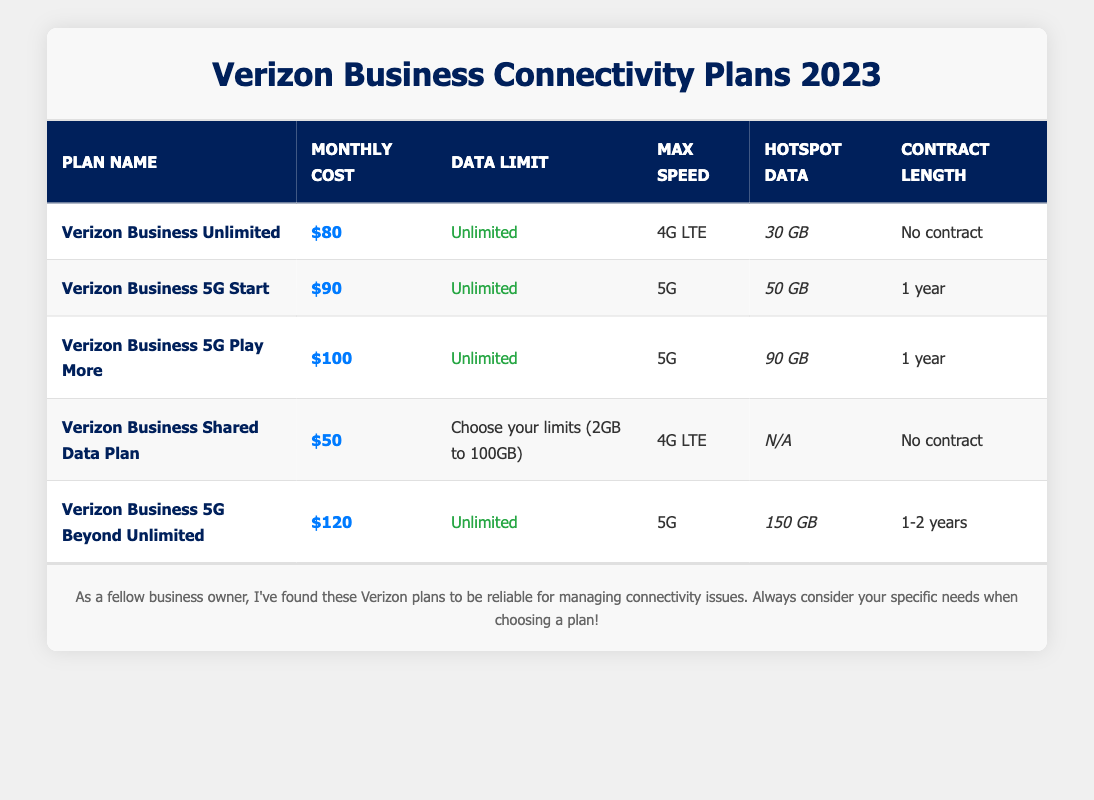What is the monthly cost of the Verizon Business Unlimited plan? The table shows that the monthly cost for the Verizon Business Unlimited plan is listed directly in the corresponding row, which is $80.
Answer: $80 How many GB of hotspot data does the Verizon Business 5G Beyond Unlimited plan offer? By looking at the specific row for the Verizon Business 5G Beyond Unlimited plan, I can see that it provides 150 GB of hotspot data.
Answer: 150 GB What is the highest monthly cost among the plans? The monthly costs listed are $80, $90, $100, $50, and $120. The highest of these values is $120 for the Verizon Business 5G Beyond Unlimited plan.
Answer: $120 Is the Verizon Business 5G Play More plan available without a contract? The table indicates that the Verizon Business 5G Play More plan has a contract length of 1 year, which means it is not available without a contract.
Answer: No What is the average monthly cost of all the plans? To find the average monthly cost, sum all the monthly costs of the plans, which are $80, $90, $100, $50, and $120, totaling $440. There are 5 plans, so dividing by 5 gives an average of $88.
Answer: $88 Which plan offers the most hotspot data, and how much is it? By examining the hotspot data in the table, the Verizon Business 5G Beyond Unlimited plan offers the most with 150 GB. This means it is the plan with the highest hotspot data.
Answer: Verizon Business 5G Beyond Unlimited plan, 150 GB How does the data limit of the Verizon Business Shared Data Plan compare to other plans? The Verizon Business Shared Data Plan allows a range of limits (2GB to 100GB) as opposed to other plans, which all offer unlimited data. Thus, its data limit is not comparable directly to the other plans that offer unlimited data.
Answer: Limited (2GB to 100GB) What is the difference in monthly cost between the cheapest and the most expensive plans? The cheapest plan is the Verizon Business Shared Data Plan at $50, and the most expensive plan is the Verizon Business 5G Beyond Unlimited at $120. Subtracting $50 from $120 gives a difference of $70.
Answer: $70 Are there any plans that allow keeping the same plan without a contract? The table indicates that the Verizon Business Unlimited and Verizon Business Shared Data plans both have 'No contract' listed, confirming that they can be kept without a contract.
Answer: Yes 